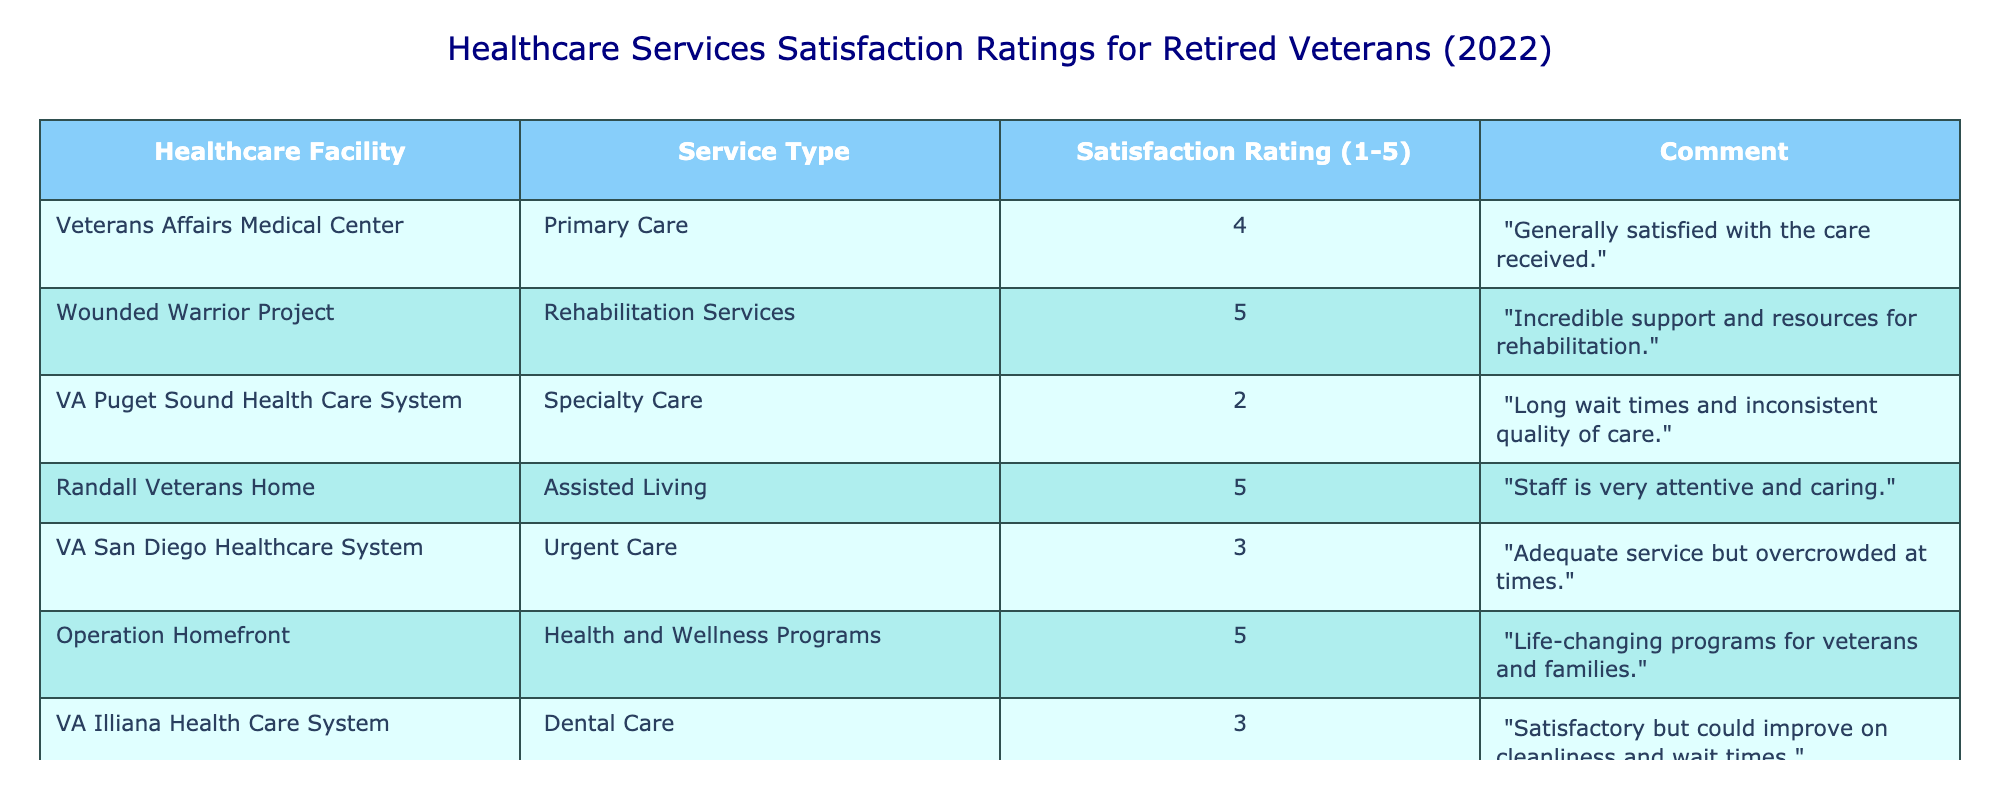What is the satisfaction rating for rehabilitation services at the Wounded Warrior Project? The table shows a satisfaction rating of 5 for rehabilitation services at the Wounded Warrior Project.
Answer: 5 How many healthcare facilities received a satisfaction rating of 3 or higher? The facilities with ratings of 3 or higher are: Veterans Affairs Medical Center (4), Wounded Warrior Project (5), Randall Veterans Home (5), Operation Homefront (5), and VA San Diego Healthcare System (3). That makes a total of 5 healthcare facilities.
Answer: 5 Is the satisfaction rating for urgent care at the VA San Diego Healthcare System higher than 4? The table indicates that the satisfaction rating for urgent care at the VA San Diego Healthcare System is 3. Since 3 is not higher than 4, the answer is no.
Answer: No What is the average satisfaction rating across all listed healthcare facilities? The satisfaction ratings are 4, 5, 2, 5, 3, 5, and 3. Adding these numbers gives 4 + 5 + 2 + 5 + 3 + 5 + 3 = 27. There are 7 facilities, so the average is 27/7 = 3.86, rounded to two decimal places.
Answer: 3.86 Which healthcare facility has the lowest satisfaction rating, and what is that rating? Looking at the ratings in the table, the VA Puget Sound Health Care System has the lowest rating of 2 for specialty care.
Answer: VA Puget Sound Health Care System, 2 Was there any healthcare facility that received a satisfaction rating of 4? The Veterans Affairs Medical Center received a rating of 4 for primary care, confirming that there is at least one healthcare facility with that rating.
Answer: Yes How many healthcare facilities offered services with a satisfaction rating of 5? Both the Wounded Warrior Project and Randall Veterans Home received a satisfaction rating of 5, along with Operation Homefront. Therefore, there are 3 facilities that offered services with this rating.
Answer: 3 What is the difference between the highest and lowest satisfaction ratings? The highest rating is 5, received by facilities like the Wounded Warrior Project and the Randall Veterans Home. The lowest rating is 2 by the VA Puget Sound Health Care System. The difference is 5 - 2 = 3.
Answer: 3 